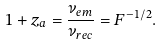Convert formula to latex. <formula><loc_0><loc_0><loc_500><loc_500>1 + z _ { a } = \frac { \nu _ { e m } } { \nu _ { r e c } } = F ^ { - 1 / 2 } .</formula> 